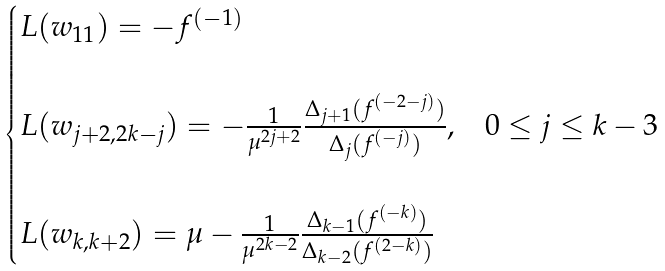<formula> <loc_0><loc_0><loc_500><loc_500>\begin{cases} L ( w _ { 1 1 } ) = - f ^ { ( - 1 ) } & \\ \\ L ( w _ { j + 2 , 2 k - j } ) = - \frac { 1 } { \mu ^ { 2 j + 2 } } \frac { \Delta _ { j + 1 } ( f ^ { ( - 2 - j ) } ) } { \Delta _ { j } ( f ^ { ( - j ) } ) } , & 0 \leq j \leq k - 3 \\ \\ L ( w _ { k , k + 2 } ) = \mu - \frac { 1 } { \mu ^ { 2 k - 2 } } \frac { \Delta _ { k - 1 } ( f ^ { ( - k ) } ) } { \Delta _ { k - 2 } ( f ^ { ( 2 - k ) } ) } \end{cases}</formula> 